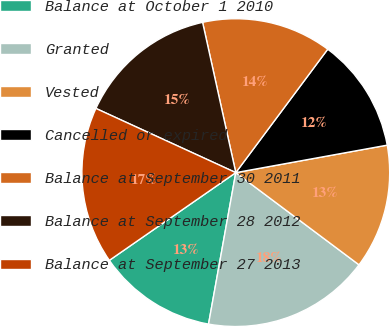<chart> <loc_0><loc_0><loc_500><loc_500><pie_chart><fcel>Balance at October 1 2010<fcel>Granted<fcel>Vested<fcel>Cancelled or expired<fcel>Balance at September 30 2011<fcel>Balance at September 28 2012<fcel>Balance at September 27 2013<nl><fcel>12.51%<fcel>17.61%<fcel>13.08%<fcel>11.95%<fcel>13.65%<fcel>14.69%<fcel>16.5%<nl></chart> 